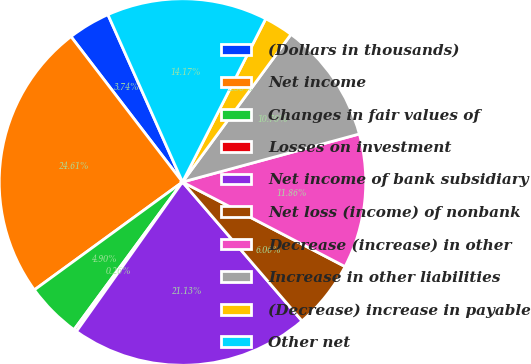Convert chart to OTSL. <chart><loc_0><loc_0><loc_500><loc_500><pie_chart><fcel>(Dollars in thousands)<fcel>Net income<fcel>Changes in fair values of<fcel>Losses on investment<fcel>Net income of bank subsidiary<fcel>Net loss (income) of nonbank<fcel>Decrease (increase) in other<fcel>Increase in other liabilities<fcel>(Decrease) increase in payable<fcel>Other net<nl><fcel>3.74%<fcel>24.62%<fcel>4.9%<fcel>0.26%<fcel>21.14%<fcel>6.06%<fcel>11.86%<fcel>10.7%<fcel>2.58%<fcel>14.18%<nl></chart> 